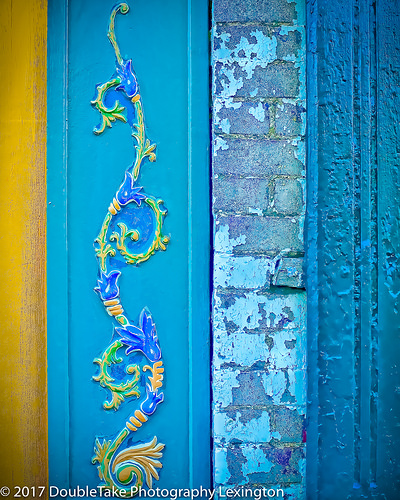<image>
Can you confirm if the crack is to the right of the brick? Yes. From this viewpoint, the crack is positioned to the right side relative to the brick. 